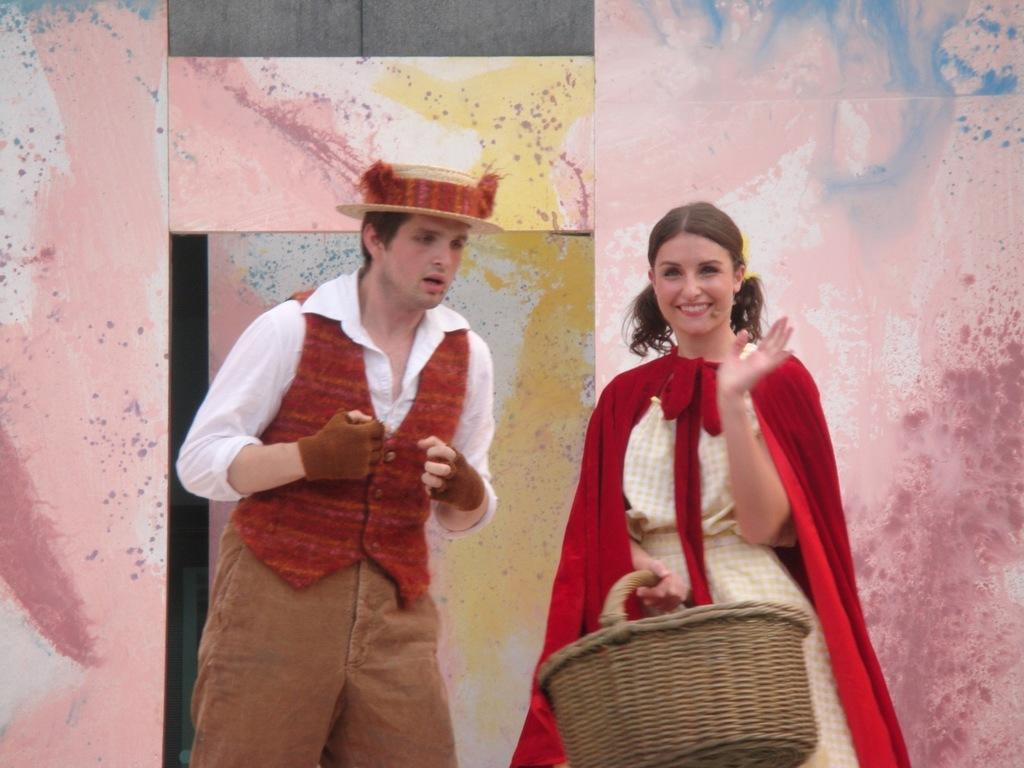How many people are in the image? There are two people in the image. What expressions do the people have? Both people are smiling. What is one of the people holding? One of the people is holding a basket in her hand. What type of structure can be seen in the image? There is a wall and a door in the image. What type of band is playing music in the image? There is no band present in the image. Is there any visible injury on the wrist of either person in the image? There is no mention of any injuries or body parts in the image, so we cannot determine if there is any visible injury on the wrist of either person. 